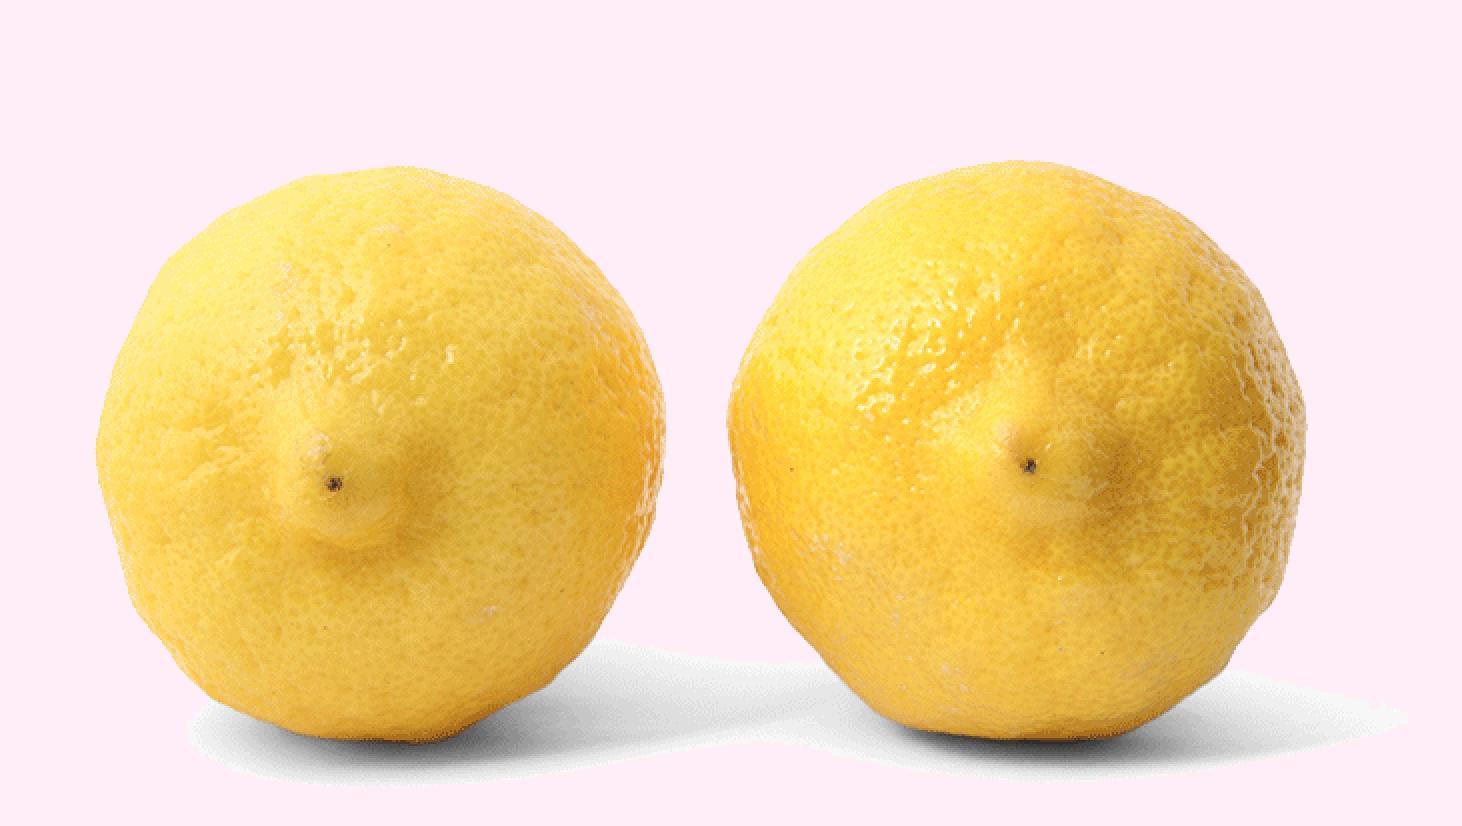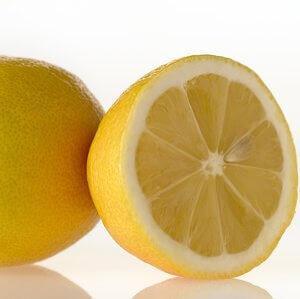The first image is the image on the left, the second image is the image on the right. Analyze the images presented: Is the assertion "The left image contains exactly two uncut lemons." valid? Answer yes or no. Yes. The first image is the image on the left, the second image is the image on the right. Given the left and right images, does the statement "One image contains exactly two intact lemons, and the other includes a lemon half." hold true? Answer yes or no. Yes. 